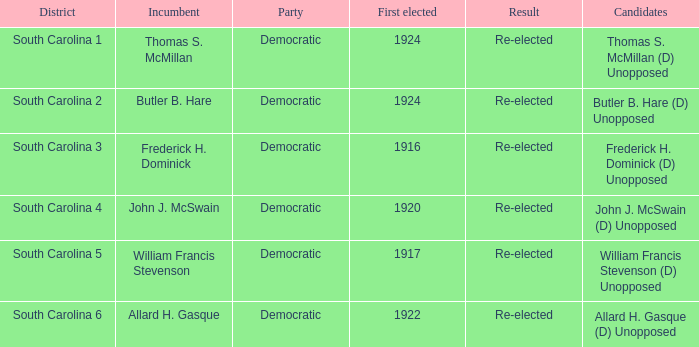What year was william francis stevenson first elected? 1917.0. 